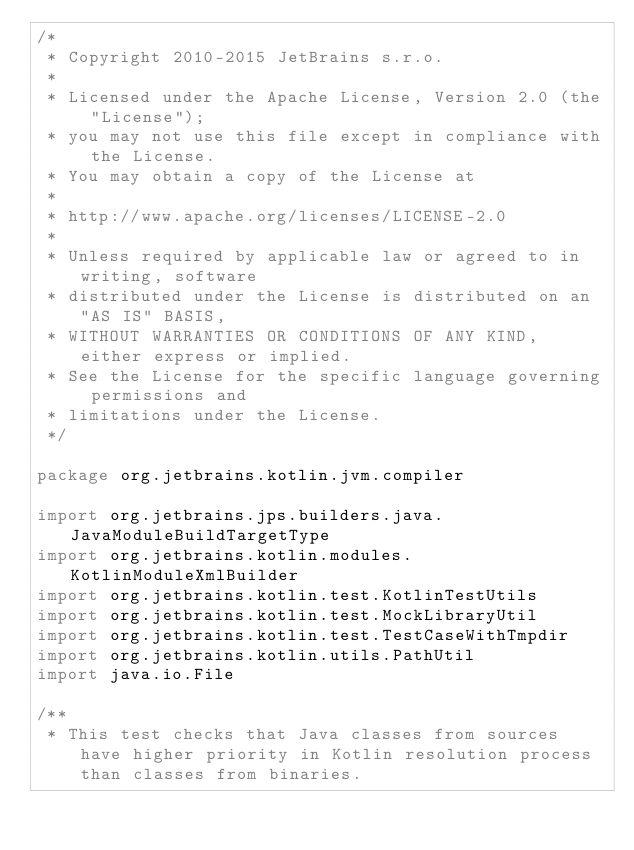Convert code to text. <code><loc_0><loc_0><loc_500><loc_500><_Kotlin_>/*
 * Copyright 2010-2015 JetBrains s.r.o.
 *
 * Licensed under the Apache License, Version 2.0 (the "License");
 * you may not use this file except in compliance with the License.
 * You may obtain a copy of the License at
 *
 * http://www.apache.org/licenses/LICENSE-2.0
 *
 * Unless required by applicable law or agreed to in writing, software
 * distributed under the License is distributed on an "AS IS" BASIS,
 * WITHOUT WARRANTIES OR CONDITIONS OF ANY KIND, either express or implied.
 * See the License for the specific language governing permissions and
 * limitations under the License.
 */

package org.jetbrains.kotlin.jvm.compiler

import org.jetbrains.jps.builders.java.JavaModuleBuildTargetType
import org.jetbrains.kotlin.modules.KotlinModuleXmlBuilder
import org.jetbrains.kotlin.test.KotlinTestUtils
import org.jetbrains.kotlin.test.MockLibraryUtil
import org.jetbrains.kotlin.test.TestCaseWithTmpdir
import org.jetbrains.kotlin.utils.PathUtil
import java.io.File

/**
 * This test checks that Java classes from sources have higher priority in Kotlin resolution process than classes from binaries.</code> 